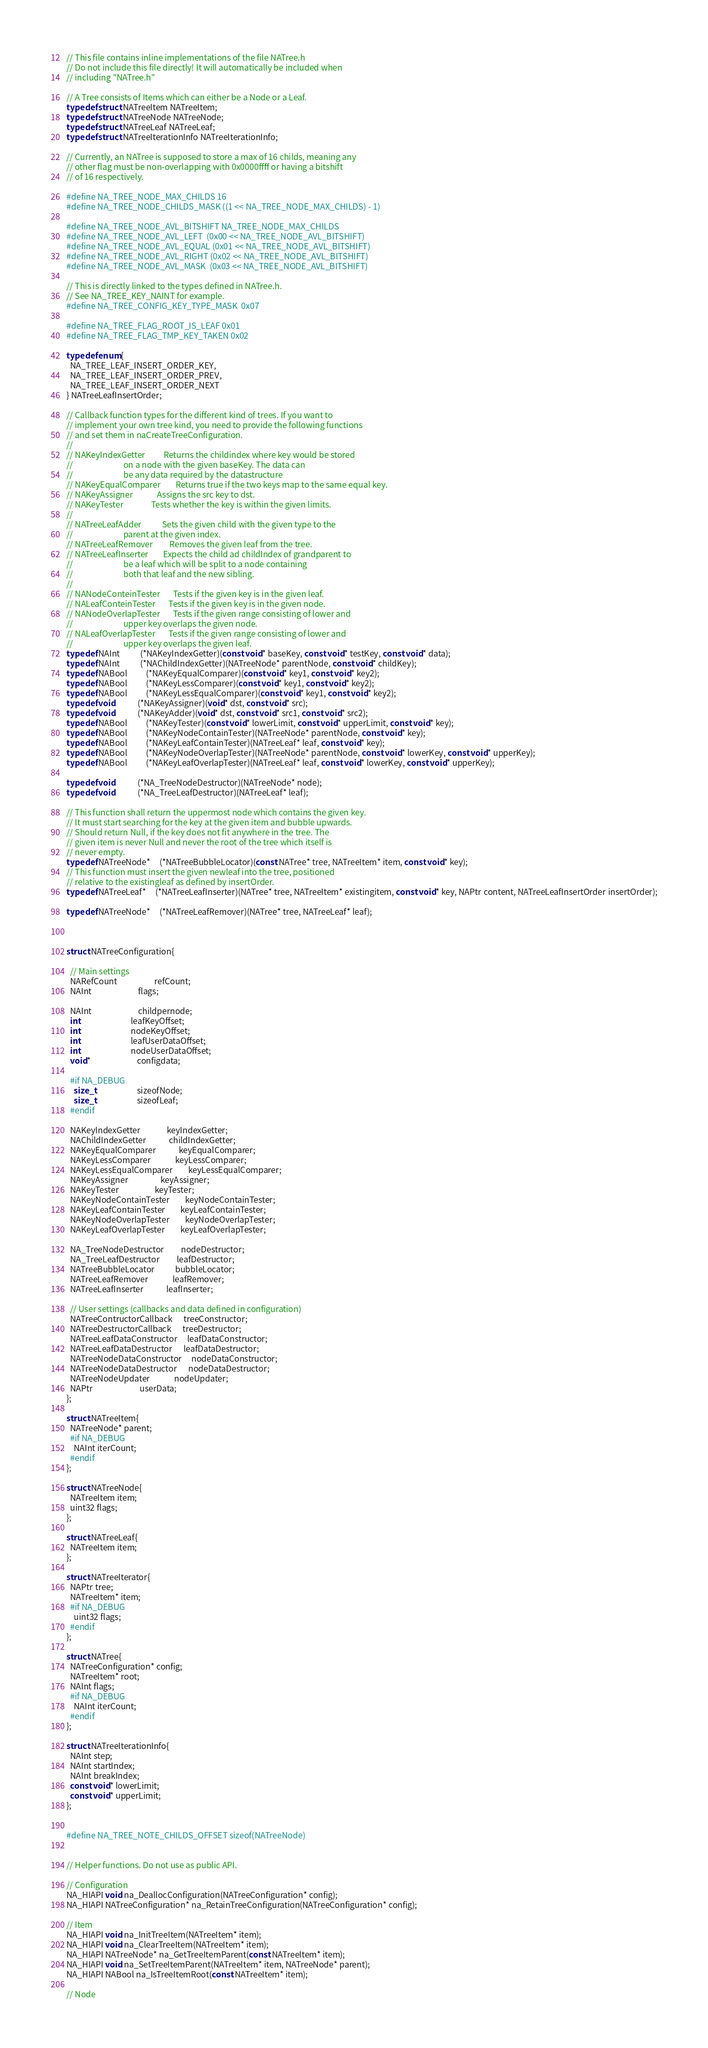<code> <loc_0><loc_0><loc_500><loc_500><_C_>
// This file contains inline implementations of the file NATree.h
// Do not include this file directly! It will automatically be included when
// including "NATree.h"

// A Tree consists of Items which can either be a Node or a Leaf.
typedef struct NATreeItem NATreeItem;
typedef struct NATreeNode NATreeNode;
typedef struct NATreeLeaf NATreeLeaf;
typedef struct NATreeIterationInfo NATreeIterationInfo;

// Currently, an NATree is supposed to store a max of 16 childs, meaning any
// other flag must be non-overlapping with 0x0000ffff or having a bitshift
// of 16 respectively.

#define NA_TREE_NODE_MAX_CHILDS 16
#define NA_TREE_NODE_CHILDS_MASK ((1 << NA_TREE_NODE_MAX_CHILDS) - 1)

#define NA_TREE_NODE_AVL_BITSHIFT NA_TREE_NODE_MAX_CHILDS
#define NA_TREE_NODE_AVL_LEFT  (0x00 << NA_TREE_NODE_AVL_BITSHIFT)
#define NA_TREE_NODE_AVL_EQUAL (0x01 << NA_TREE_NODE_AVL_BITSHIFT)
#define NA_TREE_NODE_AVL_RIGHT (0x02 << NA_TREE_NODE_AVL_BITSHIFT)
#define NA_TREE_NODE_AVL_MASK  (0x03 << NA_TREE_NODE_AVL_BITSHIFT)

// This is directly linked to the types defined in NATree.h.
// See NA_TREE_KEY_NAINT for example.
#define NA_TREE_CONFIG_KEY_TYPE_MASK  0x07

#define NA_TREE_FLAG_ROOT_IS_LEAF 0x01
#define NA_TREE_FLAG_TMP_KEY_TAKEN 0x02

typedef enum{
  NA_TREE_LEAF_INSERT_ORDER_KEY,
  NA_TREE_LEAF_INSERT_ORDER_PREV,
  NA_TREE_LEAF_INSERT_ORDER_NEXT
} NATreeLeafInsertOrder;

// Callback function types for the different kind of trees. If you want to
// implement your own tree kind, you need to provide the following functions
// and set them in naCreateTreeConfiguration.
//
// NAKeyIndexGetter          Returns the childindex where key would be stored
//                           on a node with the given baseKey. The data can
//                           be any data required by the datastructure
// NAKeyEqualComparer        Returns true if the two keys map to the same equal key.
// NAKeyAssigner             Assigns the src key to dst.
// NAKeyTester               Tests whether the key is within the given limits.
//
// NATreeLeafAdder           Sets the given child with the given type to the
//                           parent at the given index.
// NATreeLeafRemover         Removes the given leaf from the tree.
// NATreeLeafInserter        Expects the child ad childIndex of grandparent to
//                           be a leaf which will be split to a node containing
//                           both that leaf and the new sibling.
//
// NANodeConteinTester       Tests if the given key is in the given leaf.
// NALeafConteinTester       Tests if the given key is in the given node.
// NANodeOverlapTester       Tests if the given range consisting of lower and
//                           upper key overlaps the given node.
// NALeafOverlapTester       Tests if the given range consisting of lower and
//                           upper key overlaps the given leaf.
typedef NAInt           (*NAKeyIndexGetter)(const void* baseKey, const void* testKey, const void* data);
typedef NAInt           (*NAChildIndexGetter)(NATreeNode* parentNode, const void* childKey);
typedef NABool          (*NAKeyEqualComparer)(const void* key1, const void* key2);
typedef NABool          (*NAKeyLessComparer)(const void* key1, const void* key2);
typedef NABool          (*NAKeyLessEqualComparer)(const void* key1, const void* key2);
typedef void            (*NAKeyAssigner)(void* dst, const void* src);
typedef void            (*NAKeyAdder)(void* dst, const void* src1, const void* src2);
typedef NABool          (*NAKeyTester)(const void* lowerLimit, const void* upperLimit, const void* key);
typedef NABool          (*NAKeyNodeContainTester)(NATreeNode* parentNode, const void* key);
typedef NABool          (*NAKeyLeafContainTester)(NATreeLeaf* leaf, const void* key);
typedef NABool          (*NAKeyNodeOverlapTester)(NATreeNode* parentNode, const void* lowerKey, const void* upperKey);
typedef NABool          (*NAKeyLeafOverlapTester)(NATreeLeaf* leaf, const void* lowerKey, const void* upperKey);

typedef void            (*NA_TreeNodeDestructor)(NATreeNode* node);
typedef void            (*NA_TreeLeafDestructor)(NATreeLeaf* leaf);

// This function shall return the uppermost node which contains the given key.
// It must start searching for the key at the given item and bubble upwards.
// Should return Null, if the key does not fit anywhere in the tree. The
// given item is never Null and never the root of the tree which itself is
// never empty.
typedef NATreeNode*     (*NATreeBubbleLocator)(const NATree* tree, NATreeItem* item, const void* key);
// This function must insert the given newleaf into the tree, positioned
// relative to the existingleaf as defined by insertOrder.
typedef NATreeLeaf*     (*NATreeLeafInserter)(NATree* tree, NATreeItem* existingitem, const void* key, NAPtr content, NATreeLeafInsertOrder insertOrder);

typedef NATreeNode*     (*NATreeLeafRemover)(NATree* tree, NATreeLeaf* leaf);



struct NATreeConfiguration{
  
  // Main settings
  NARefCount                    refCount;
  NAInt                         flags;

  NAInt                         childpernode;
  int                           leafKeyOffset;
  int                           nodeKeyOffset;
  int                           leafUserDataOffset;
  int                           nodeUserDataOffset;
  void*                         configdata;

  #if NA_DEBUG
    size_t                      sizeofNode;
    size_t                      sizeofLeaf;
  #endif

  NAKeyIndexGetter              keyIndexGetter;
  NAChildIndexGetter            childIndexGetter;
  NAKeyEqualComparer            keyEqualComparer;
  NAKeyLessComparer             keyLessComparer;
  NAKeyLessEqualComparer        keyLessEqualComparer;
  NAKeyAssigner                 keyAssigner;
  NAKeyTester                   keyTester;
  NAKeyNodeContainTester        keyNodeContainTester;
  NAKeyLeafContainTester        keyLeafContainTester;
  NAKeyNodeOverlapTester        keyNodeOverlapTester;
  NAKeyLeafOverlapTester        keyLeafOverlapTester;

  NA_TreeNodeDestructor         nodeDestructor;
  NA_TreeLeafDestructor         leafDestructor;
  NATreeBubbleLocator           bubbleLocator;
  NATreeLeafRemover             leafRemover;
  NATreeLeafInserter            leafInserter;

  // User settings (callbacks and data defined in configuration)
  NATreeContructorCallback      treeConstructor;
  NATreeDestructorCallback      treeDestructor;
  NATreeLeafDataConstructor     leafDataConstructor;
  NATreeLeafDataDestructor      leafDataDestructor;
  NATreeNodeDataConstructor     nodeDataConstructor;
  NATreeNodeDataDestructor      nodeDataDestructor;
  NATreeNodeUpdater             nodeUpdater;
  NAPtr                         userData;
};

struct NATreeItem{
  NATreeNode* parent;
  #if NA_DEBUG
    NAInt iterCount;
  #endif
};

struct NATreeNode{
  NATreeItem item;
  uint32 flags;
};

struct NATreeLeaf{
  NATreeItem item;
};

struct NATreeIterator{
  NAPtr tree;
  NATreeItem* item;
  #if NA_DEBUG
    uint32 flags;
  #endif
};

struct NATree{
  NATreeConfiguration* config;
  NATreeItem* root;
  NAInt flags;
  #if NA_DEBUG
    NAInt iterCount;
  #endif
};

struct NATreeIterationInfo{
  NAInt step;
  NAInt startIndex;
  NAInt breakIndex;
  const void* lowerLimit;
  const void* upperLimit;
};


#define NA_TREE_NOTE_CHILDS_OFFSET sizeof(NATreeNode)


// Helper functions. Do not use as public API.

// Configuration
NA_HIAPI void na_DeallocConfiguration(NATreeConfiguration* config);
NA_HIAPI NATreeConfiguration* na_RetainTreeConfiguration(NATreeConfiguration* config);

// Item
NA_HIAPI void na_InitTreeItem(NATreeItem* item);
NA_HIAPI void na_ClearTreeItem(NATreeItem* item);
NA_HIAPI NATreeNode* na_GetTreeItemParent(const NATreeItem* item);
NA_HIAPI void na_SetTreeItemParent(NATreeItem* item, NATreeNode* parent);
NA_HIAPI NABool na_IsTreeItemRoot(const NATreeItem* item);

// Node</code> 